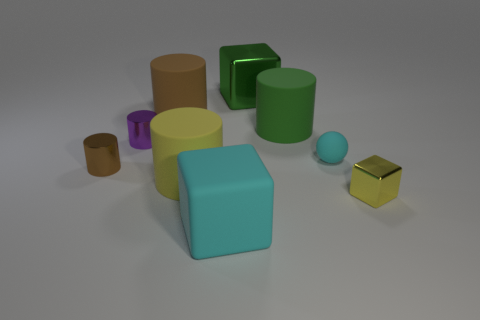Which object stands out the most, and why might that be? The golden-yellow cube stands out the most due to its bright, reflective surface, which contrasts sharply with the matte textures of the other objects. 